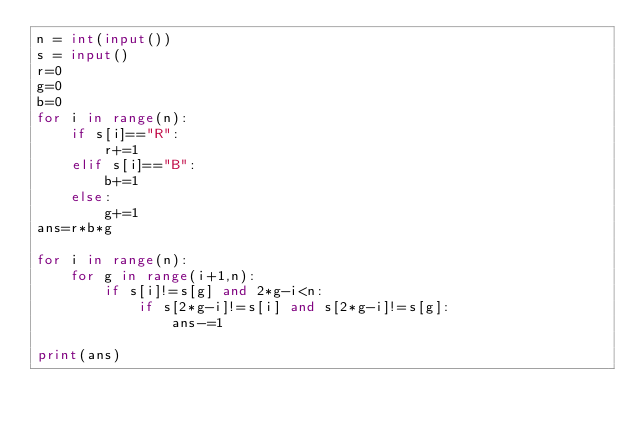Convert code to text. <code><loc_0><loc_0><loc_500><loc_500><_Python_>n = int(input())
s = input()
r=0
g=0
b=0
for i in range(n):
    if s[i]=="R":
        r+=1
    elif s[i]=="B":
        b+=1
    else:
        g+=1
ans=r*b*g

for i in range(n):
    for g in range(i+1,n):
        if s[i]!=s[g] and 2*g-i<n:
            if s[2*g-i]!=s[i] and s[2*g-i]!=s[g]:
                ans-=1

print(ans)</code> 